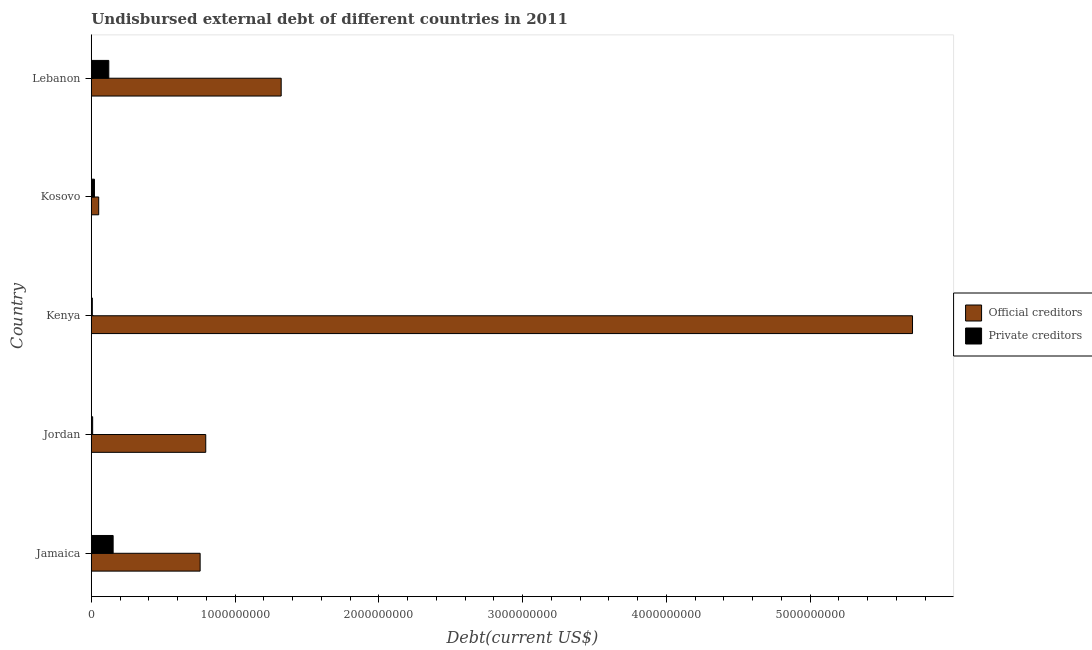How many different coloured bars are there?
Give a very brief answer. 2. How many groups of bars are there?
Give a very brief answer. 5. Are the number of bars on each tick of the Y-axis equal?
Keep it short and to the point. Yes. How many bars are there on the 5th tick from the top?
Make the answer very short. 2. How many bars are there on the 5th tick from the bottom?
Give a very brief answer. 2. What is the label of the 1st group of bars from the top?
Your answer should be compact. Lebanon. In how many cases, is the number of bars for a given country not equal to the number of legend labels?
Offer a very short reply. 0. What is the undisbursed external debt of private creditors in Jordan?
Offer a terse response. 9.48e+06. Across all countries, what is the maximum undisbursed external debt of official creditors?
Ensure brevity in your answer.  5.71e+09. Across all countries, what is the minimum undisbursed external debt of private creditors?
Give a very brief answer. 7.11e+06. In which country was the undisbursed external debt of private creditors maximum?
Your answer should be very brief. Jamaica. In which country was the undisbursed external debt of official creditors minimum?
Give a very brief answer. Kosovo. What is the total undisbursed external debt of private creditors in the graph?
Make the answer very short. 3.12e+08. What is the difference between the undisbursed external debt of official creditors in Jamaica and that in Lebanon?
Your response must be concise. -5.64e+08. What is the difference between the undisbursed external debt of private creditors in Jamaica and the undisbursed external debt of official creditors in Jordan?
Your answer should be compact. -6.44e+08. What is the average undisbursed external debt of private creditors per country?
Provide a succinct answer. 6.25e+07. What is the difference between the undisbursed external debt of official creditors and undisbursed external debt of private creditors in Kenya?
Your answer should be very brief. 5.71e+09. In how many countries, is the undisbursed external debt of private creditors greater than 3400000000 US$?
Provide a succinct answer. 0. What is the ratio of the undisbursed external debt of private creditors in Jamaica to that in Jordan?
Your response must be concise. 16.04. Is the undisbursed external debt of private creditors in Jordan less than that in Kosovo?
Ensure brevity in your answer.  Yes. Is the difference between the undisbursed external debt of official creditors in Jamaica and Lebanon greater than the difference between the undisbursed external debt of private creditors in Jamaica and Lebanon?
Your answer should be compact. No. What is the difference between the highest and the second highest undisbursed external debt of official creditors?
Keep it short and to the point. 4.39e+09. What is the difference between the highest and the lowest undisbursed external debt of official creditors?
Offer a very short reply. 5.66e+09. In how many countries, is the undisbursed external debt of official creditors greater than the average undisbursed external debt of official creditors taken over all countries?
Make the answer very short. 1. Is the sum of the undisbursed external debt of private creditors in Jordan and Kosovo greater than the maximum undisbursed external debt of official creditors across all countries?
Your response must be concise. No. What does the 1st bar from the top in Jamaica represents?
Offer a very short reply. Private creditors. What does the 1st bar from the bottom in Lebanon represents?
Your answer should be very brief. Official creditors. How many bars are there?
Give a very brief answer. 10. Are all the bars in the graph horizontal?
Offer a terse response. Yes. What is the difference between two consecutive major ticks on the X-axis?
Offer a terse response. 1.00e+09. Are the values on the major ticks of X-axis written in scientific E-notation?
Keep it short and to the point. No. Does the graph contain grids?
Your answer should be very brief. No. Where does the legend appear in the graph?
Your answer should be compact. Center right. What is the title of the graph?
Your answer should be very brief. Undisbursed external debt of different countries in 2011. Does "Age 15+" appear as one of the legend labels in the graph?
Ensure brevity in your answer.  No. What is the label or title of the X-axis?
Keep it short and to the point. Debt(current US$). What is the label or title of the Y-axis?
Keep it short and to the point. Country. What is the Debt(current US$) in Official creditors in Jamaica?
Ensure brevity in your answer.  7.57e+08. What is the Debt(current US$) in Private creditors in Jamaica?
Ensure brevity in your answer.  1.52e+08. What is the Debt(current US$) in Official creditors in Jordan?
Keep it short and to the point. 7.96e+08. What is the Debt(current US$) in Private creditors in Jordan?
Keep it short and to the point. 9.48e+06. What is the Debt(current US$) of Official creditors in Kenya?
Provide a succinct answer. 5.71e+09. What is the Debt(current US$) in Private creditors in Kenya?
Your answer should be very brief. 7.11e+06. What is the Debt(current US$) in Official creditors in Kosovo?
Offer a very short reply. 5.16e+07. What is the Debt(current US$) of Private creditors in Kosovo?
Keep it short and to the point. 2.20e+07. What is the Debt(current US$) in Official creditors in Lebanon?
Give a very brief answer. 1.32e+09. What is the Debt(current US$) in Private creditors in Lebanon?
Make the answer very short. 1.22e+08. Across all countries, what is the maximum Debt(current US$) in Official creditors?
Provide a short and direct response. 5.71e+09. Across all countries, what is the maximum Debt(current US$) in Private creditors?
Keep it short and to the point. 1.52e+08. Across all countries, what is the minimum Debt(current US$) of Official creditors?
Make the answer very short. 5.16e+07. Across all countries, what is the minimum Debt(current US$) in Private creditors?
Make the answer very short. 7.11e+06. What is the total Debt(current US$) in Official creditors in the graph?
Ensure brevity in your answer.  8.64e+09. What is the total Debt(current US$) of Private creditors in the graph?
Your response must be concise. 3.12e+08. What is the difference between the Debt(current US$) of Official creditors in Jamaica and that in Jordan?
Offer a terse response. -3.90e+07. What is the difference between the Debt(current US$) of Private creditors in Jamaica and that in Jordan?
Offer a very short reply. 1.43e+08. What is the difference between the Debt(current US$) of Official creditors in Jamaica and that in Kenya?
Make the answer very short. -4.96e+09. What is the difference between the Debt(current US$) in Private creditors in Jamaica and that in Kenya?
Provide a short and direct response. 1.45e+08. What is the difference between the Debt(current US$) in Official creditors in Jamaica and that in Kosovo?
Provide a succinct answer. 7.06e+08. What is the difference between the Debt(current US$) in Private creditors in Jamaica and that in Kosovo?
Keep it short and to the point. 1.30e+08. What is the difference between the Debt(current US$) of Official creditors in Jamaica and that in Lebanon?
Provide a succinct answer. -5.64e+08. What is the difference between the Debt(current US$) in Private creditors in Jamaica and that in Lebanon?
Provide a short and direct response. 3.02e+07. What is the difference between the Debt(current US$) in Official creditors in Jordan and that in Kenya?
Give a very brief answer. -4.92e+09. What is the difference between the Debt(current US$) in Private creditors in Jordan and that in Kenya?
Ensure brevity in your answer.  2.37e+06. What is the difference between the Debt(current US$) of Official creditors in Jordan and that in Kosovo?
Make the answer very short. 7.45e+08. What is the difference between the Debt(current US$) of Private creditors in Jordan and that in Kosovo?
Your answer should be very brief. -1.25e+07. What is the difference between the Debt(current US$) of Official creditors in Jordan and that in Lebanon?
Keep it short and to the point. -5.25e+08. What is the difference between the Debt(current US$) of Private creditors in Jordan and that in Lebanon?
Your answer should be compact. -1.12e+08. What is the difference between the Debt(current US$) in Official creditors in Kenya and that in Kosovo?
Keep it short and to the point. 5.66e+09. What is the difference between the Debt(current US$) in Private creditors in Kenya and that in Kosovo?
Provide a short and direct response. -1.49e+07. What is the difference between the Debt(current US$) in Official creditors in Kenya and that in Lebanon?
Keep it short and to the point. 4.39e+09. What is the difference between the Debt(current US$) in Private creditors in Kenya and that in Lebanon?
Ensure brevity in your answer.  -1.15e+08. What is the difference between the Debt(current US$) in Official creditors in Kosovo and that in Lebanon?
Your response must be concise. -1.27e+09. What is the difference between the Debt(current US$) in Private creditors in Kosovo and that in Lebanon?
Your response must be concise. -9.98e+07. What is the difference between the Debt(current US$) in Official creditors in Jamaica and the Debt(current US$) in Private creditors in Jordan?
Keep it short and to the point. 7.48e+08. What is the difference between the Debt(current US$) of Official creditors in Jamaica and the Debt(current US$) of Private creditors in Kenya?
Offer a very short reply. 7.50e+08. What is the difference between the Debt(current US$) in Official creditors in Jamaica and the Debt(current US$) in Private creditors in Kosovo?
Give a very brief answer. 7.35e+08. What is the difference between the Debt(current US$) of Official creditors in Jamaica and the Debt(current US$) of Private creditors in Lebanon?
Your answer should be very brief. 6.35e+08. What is the difference between the Debt(current US$) in Official creditors in Jordan and the Debt(current US$) in Private creditors in Kenya?
Make the answer very short. 7.89e+08. What is the difference between the Debt(current US$) of Official creditors in Jordan and the Debt(current US$) of Private creditors in Kosovo?
Make the answer very short. 7.74e+08. What is the difference between the Debt(current US$) of Official creditors in Jordan and the Debt(current US$) of Private creditors in Lebanon?
Provide a short and direct response. 6.74e+08. What is the difference between the Debt(current US$) of Official creditors in Kenya and the Debt(current US$) of Private creditors in Kosovo?
Provide a short and direct response. 5.69e+09. What is the difference between the Debt(current US$) of Official creditors in Kenya and the Debt(current US$) of Private creditors in Lebanon?
Provide a succinct answer. 5.59e+09. What is the difference between the Debt(current US$) in Official creditors in Kosovo and the Debt(current US$) in Private creditors in Lebanon?
Offer a very short reply. -7.02e+07. What is the average Debt(current US$) of Official creditors per country?
Provide a succinct answer. 1.73e+09. What is the average Debt(current US$) in Private creditors per country?
Ensure brevity in your answer.  6.25e+07. What is the difference between the Debt(current US$) of Official creditors and Debt(current US$) of Private creditors in Jamaica?
Your response must be concise. 6.05e+08. What is the difference between the Debt(current US$) in Official creditors and Debt(current US$) in Private creditors in Jordan?
Offer a terse response. 7.87e+08. What is the difference between the Debt(current US$) of Official creditors and Debt(current US$) of Private creditors in Kenya?
Provide a succinct answer. 5.71e+09. What is the difference between the Debt(current US$) of Official creditors and Debt(current US$) of Private creditors in Kosovo?
Make the answer very short. 2.96e+07. What is the difference between the Debt(current US$) in Official creditors and Debt(current US$) in Private creditors in Lebanon?
Provide a short and direct response. 1.20e+09. What is the ratio of the Debt(current US$) in Official creditors in Jamaica to that in Jordan?
Provide a succinct answer. 0.95. What is the ratio of the Debt(current US$) of Private creditors in Jamaica to that in Jordan?
Your answer should be compact. 16.04. What is the ratio of the Debt(current US$) in Official creditors in Jamaica to that in Kenya?
Your answer should be very brief. 0.13. What is the ratio of the Debt(current US$) of Private creditors in Jamaica to that in Kenya?
Ensure brevity in your answer.  21.39. What is the ratio of the Debt(current US$) of Official creditors in Jamaica to that in Kosovo?
Your answer should be very brief. 14.68. What is the ratio of the Debt(current US$) of Private creditors in Jamaica to that in Kosovo?
Ensure brevity in your answer.  6.91. What is the ratio of the Debt(current US$) in Official creditors in Jamaica to that in Lebanon?
Your response must be concise. 0.57. What is the ratio of the Debt(current US$) in Private creditors in Jamaica to that in Lebanon?
Give a very brief answer. 1.25. What is the ratio of the Debt(current US$) of Official creditors in Jordan to that in Kenya?
Give a very brief answer. 0.14. What is the ratio of the Debt(current US$) of Private creditors in Jordan to that in Kenya?
Offer a terse response. 1.33. What is the ratio of the Debt(current US$) in Official creditors in Jordan to that in Kosovo?
Your answer should be very brief. 15.43. What is the ratio of the Debt(current US$) of Private creditors in Jordan to that in Kosovo?
Your response must be concise. 0.43. What is the ratio of the Debt(current US$) in Official creditors in Jordan to that in Lebanon?
Your answer should be compact. 0.6. What is the ratio of the Debt(current US$) in Private creditors in Jordan to that in Lebanon?
Provide a succinct answer. 0.08. What is the ratio of the Debt(current US$) of Official creditors in Kenya to that in Kosovo?
Offer a very short reply. 110.74. What is the ratio of the Debt(current US$) of Private creditors in Kenya to that in Kosovo?
Make the answer very short. 0.32. What is the ratio of the Debt(current US$) of Official creditors in Kenya to that in Lebanon?
Offer a terse response. 4.32. What is the ratio of the Debt(current US$) in Private creditors in Kenya to that in Lebanon?
Keep it short and to the point. 0.06. What is the ratio of the Debt(current US$) in Official creditors in Kosovo to that in Lebanon?
Ensure brevity in your answer.  0.04. What is the ratio of the Debt(current US$) of Private creditors in Kosovo to that in Lebanon?
Offer a terse response. 0.18. What is the difference between the highest and the second highest Debt(current US$) in Official creditors?
Keep it short and to the point. 4.39e+09. What is the difference between the highest and the second highest Debt(current US$) of Private creditors?
Make the answer very short. 3.02e+07. What is the difference between the highest and the lowest Debt(current US$) of Official creditors?
Offer a terse response. 5.66e+09. What is the difference between the highest and the lowest Debt(current US$) in Private creditors?
Make the answer very short. 1.45e+08. 